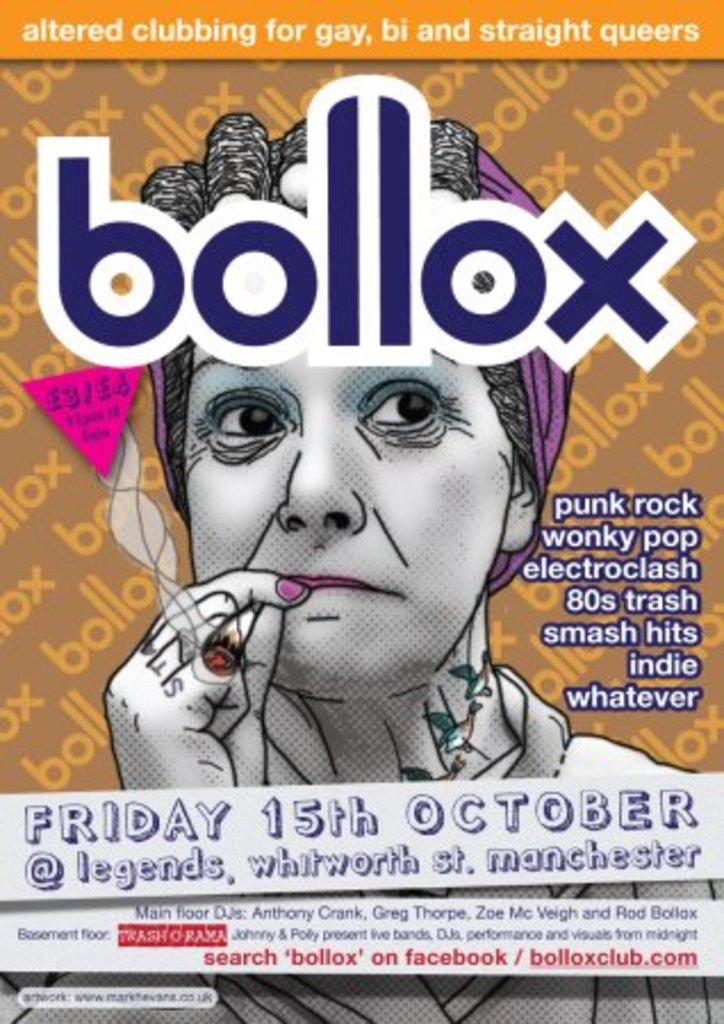<image>
Describe the image concisely. Poster for bollox which takes place on October 15th. 